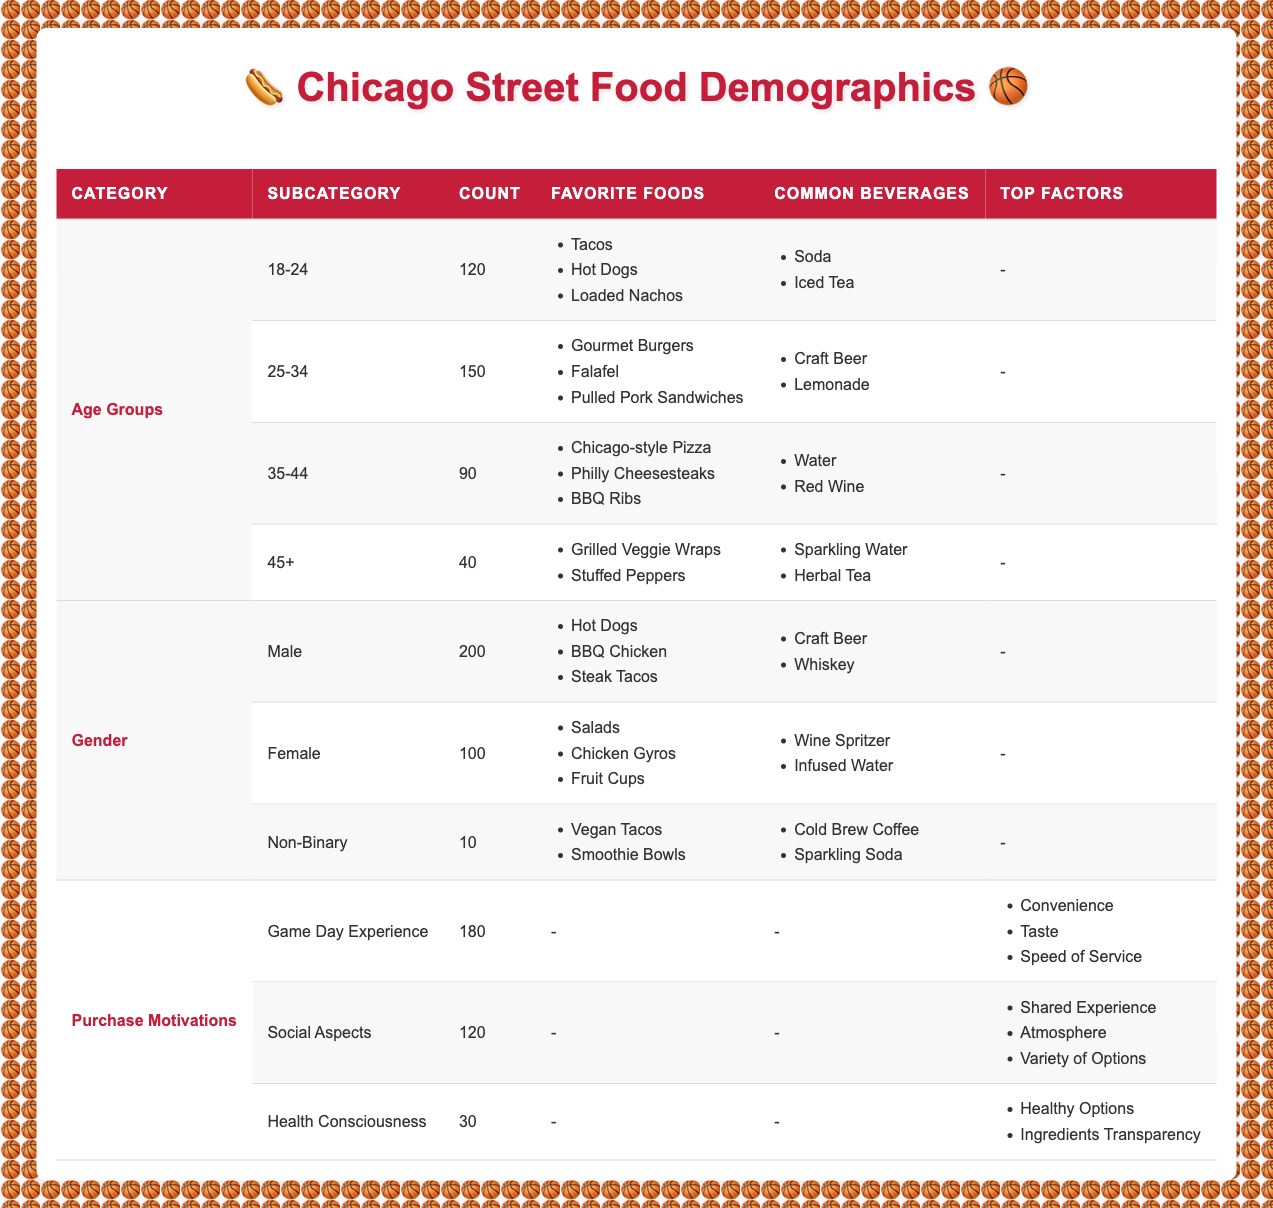What is the favorite food of the 25-34 age group? The 25-34 age group has listed their favorite foods as Gourmet Burgers, Falafel, and Pulled Pork Sandwiches, which can be found directly in the table under the Favorite Foods column for that age group.
Answer: Gourmet Burgers, Falafel, Pulled Pork Sandwiches How many female customers prefer salads? According to the Gender section in the table, the count for female customers is mentioned as 100, with their favorite foods including Salads, Chicken Gyros, and Fruit Cups. The question specifically concerns salads, which are a favorite of female customers included in this count.
Answer: 100 What is the total number of customers across all age groups? To find the total number of customers across all age groups, sum the counts: 120 (18-24) + 150 (25-34) + 90 (35-44) + 40 (45+) = 400 total customers. This requires adding the counts from each age group.
Answer: 400 Is the common beverage among 35-44-year-olds water? The table indicates that, for the 35-44 age group, the common beverages are Water and Red Wine. Since the question is about whether water is a common beverage, it can be confirmed directly from the data provided.
Answer: Yes Which age group has the highest number of customers? From the Age Groups section, the counts are 120 (18-24), 150 (25-34), 90 (35-44), and 40 (45+). The 25-34 age group has the highest count at 150. This can be found by comparing the numerical values in the Count column.
Answer: 25-34 What percentage of the total customer base comes from the Game Day Experience motivation? First, we need to determine the total count of customers motivated by Game Day Experience, which is 180. Next, we find the total customer base, which we already know is 400. Then the percentage is calculated as (180/400) * 100 = 45%. This requires knowledge of both totals to compute the percentage accurately.
Answer: 45% Do non-binary customers favor hot dogs? The non-binary customers, according to the table, list their favorite foods as Vegan Tacos and Smoothie Bowls, with no mention of hot dogs. Therefore, this statement can be assessed from the data directly.
Answer: No What factors do customers consider most important for the Game Day Experience? The table lists the Top Factors for Game Day Experience as Convenience, Taste, and Speed of Service. This information is clearly stated under the respective row for Game Day Experience in the Purchase Motivations section of the table.
Answer: Convenience, Taste, Speed of Service 